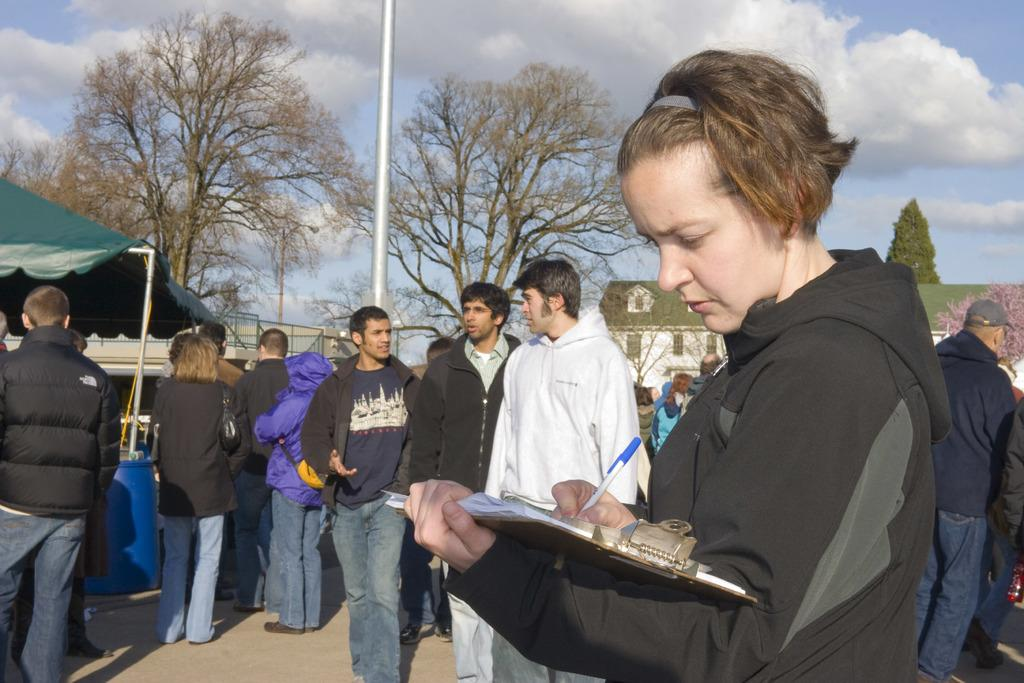How many people are in the image? There are people in the image, but the exact number is not specified. What is one person doing in the image? One person is writing with a pen on paper. What type of structure can be seen in the image? There is a tent in the image. What other objects are present in the image? There is a barrel and a pole in the image. What type of buildings can be seen in the image? There are houses in the image. What type of natural environment is visible in the image? There are trees in the image. What part of the natural environment is visible in the image? The sky is visible in the image. What type of tail can be seen on the person writing in the image? There is no tail present on the person writing in the image. What suggestion is being made by the person writing in the image? The image does not provide any information about the content of the writing or any suggestions being made. 